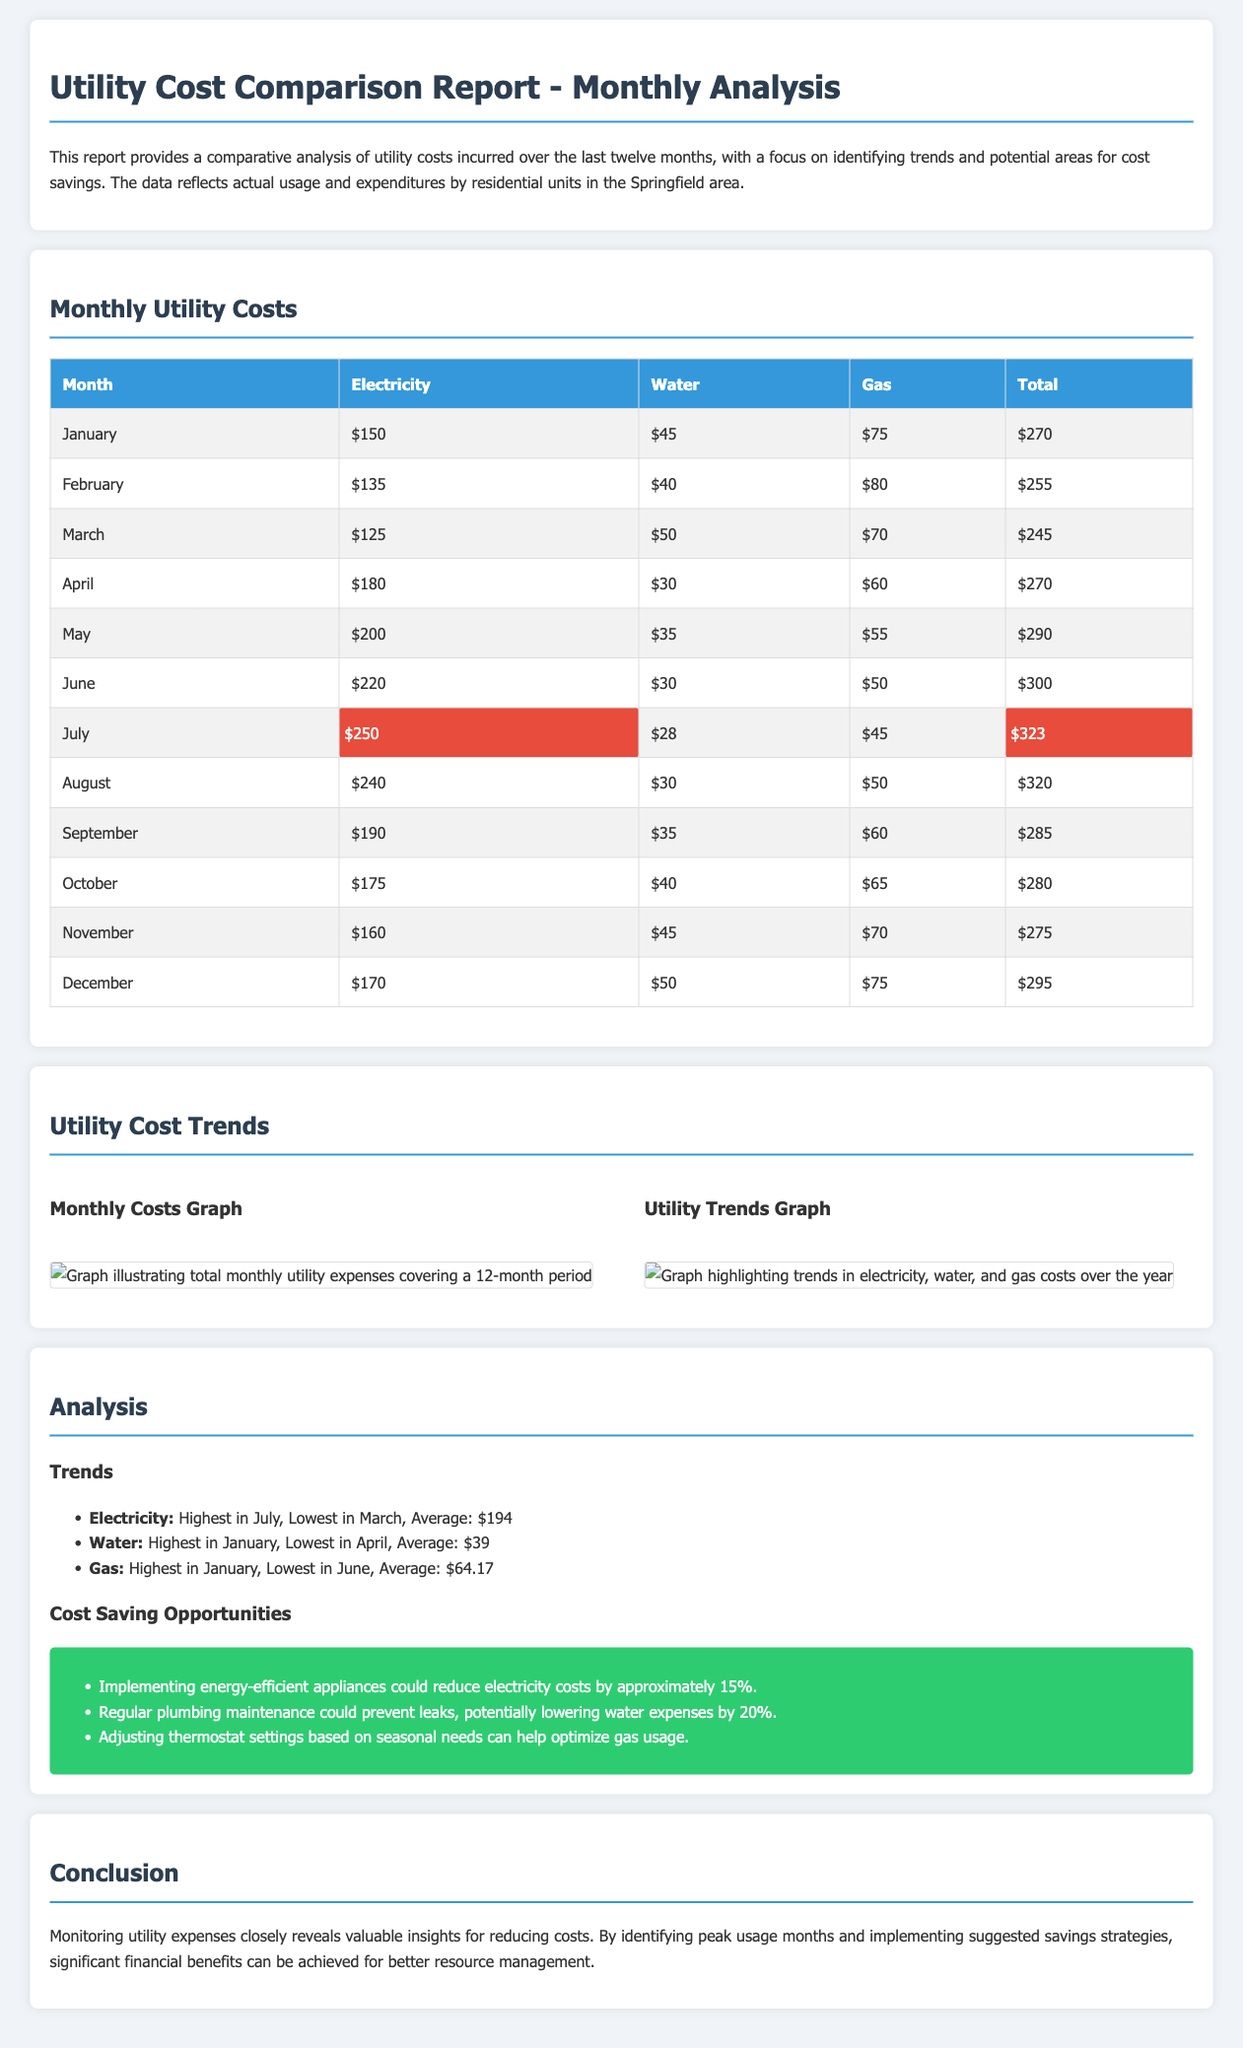What was the highest electricity cost in a month? The table shows that July had the highest electricity cost of $250.
Answer: $250 What month had the lowest water cost? From the monthly costs table, April has the lowest water cost at $30.
Answer: $30 What is the average gas cost over the year? The analysis lists the average gas cost as $64.17 based on the monthly totals.
Answer: $64.17 Which month did the total utility cost exceed $300? The data indicates that June was the month with total costs exceeding $300, amounting to $300.
Answer: June What is one potential area for cost savings suggested in the report? The report suggests that implementing energy-efficient appliances could reduce electricity costs by approximately 15%.
Answer: Energy-efficient appliances How much could regular plumbing maintenance potentially lower water expenses? The report states that regular plumbing maintenance could lower water expenses by 20%.
Answer: 20% Which month recorded the lowest total utility cost? The month with the lowest total utility cost is March, totaling $245.
Answer: March What is the highest monthly cost observed across all utilities? The total cost for July is highlighted as the highest monthly cost at $323.
Answer: $323 